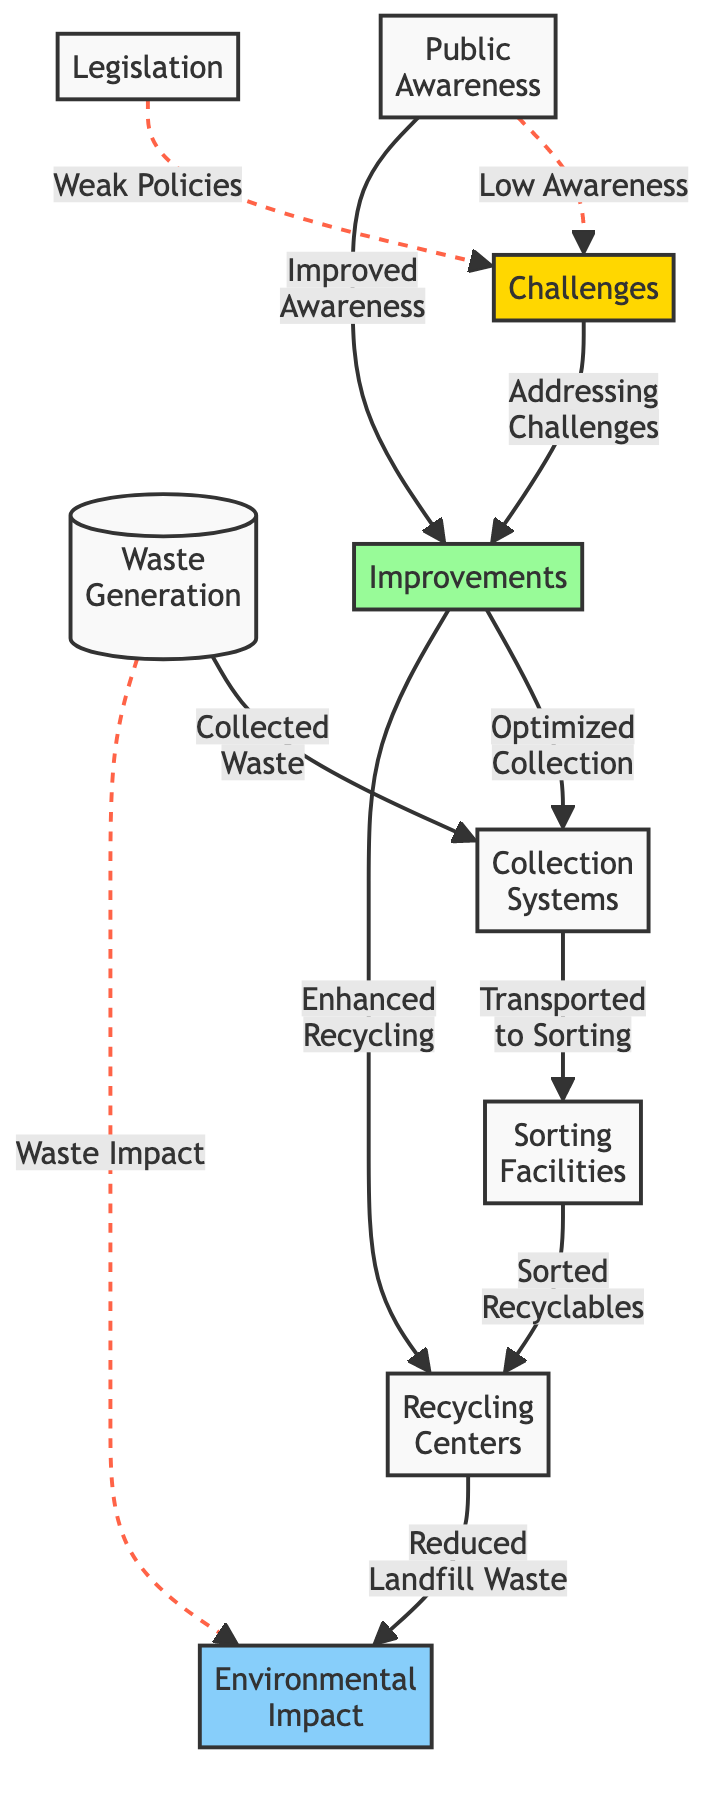What's the first node in the diagram? The diagram starts with the node labeled "Waste Generation," which indicates the initial stage of the waste management process.
Answer: Waste Generation How many nodes are in the diagram? The diagram has a total of 9 nodes, including both challenges and improvements.
Answer: 9 What does the node "Sorting Facilities" connect to? The "Sorting Facilities" node connects to the "Recycling Centers" node, indicating the flow of sorted recyclables to further processing.
Answer: Recycling Centers What is the challenge linked to "Public Awareness"? The challenge linked to "Public Awareness" is labeled "Low Awareness," indicating that a lack of public knowledge affects the waste management process.
Answer: Low Awareness What are the two improvements suggested in the diagram? The suggested improvements are "Optimized Collection" and "Enhanced Recycling." These aim to address challenges in waste management and improve overall efficiency.
Answer: Optimized Collection; Enhanced Recycling Which node has a direct connection to "Environmental Impact"? The node "Recycling Centers" has a direct connection to the "Environmental Impact" node, showing that improved recycling practices contribute to reduced landfill waste and positive environmental outcomes.
Answer: Recycling Centers How does weak legislation impact waste management? Weak legislation is identified as a challenge, linking to "Challenges" and suggesting that insufficient policies hinder effective waste management practices in the city.
Answer: Weak Policies What relationship exists between "Addressing Challenges" and "Improvements"? "Addressing Challenges" directly leads to "Improvements," indicating that tackling the identified challenges will result in progress in waste management practices.
Answer: Improvements Which two nodes are connected by a dashed line indicating a challenge? The nodes "Low Awareness" and "Weak Policies" are connected by dashed lines to the "Challenges" node, highlighting that these factors contribute to the difficulties faced in waste management.
Answer: Low Awareness; Weak Policies 